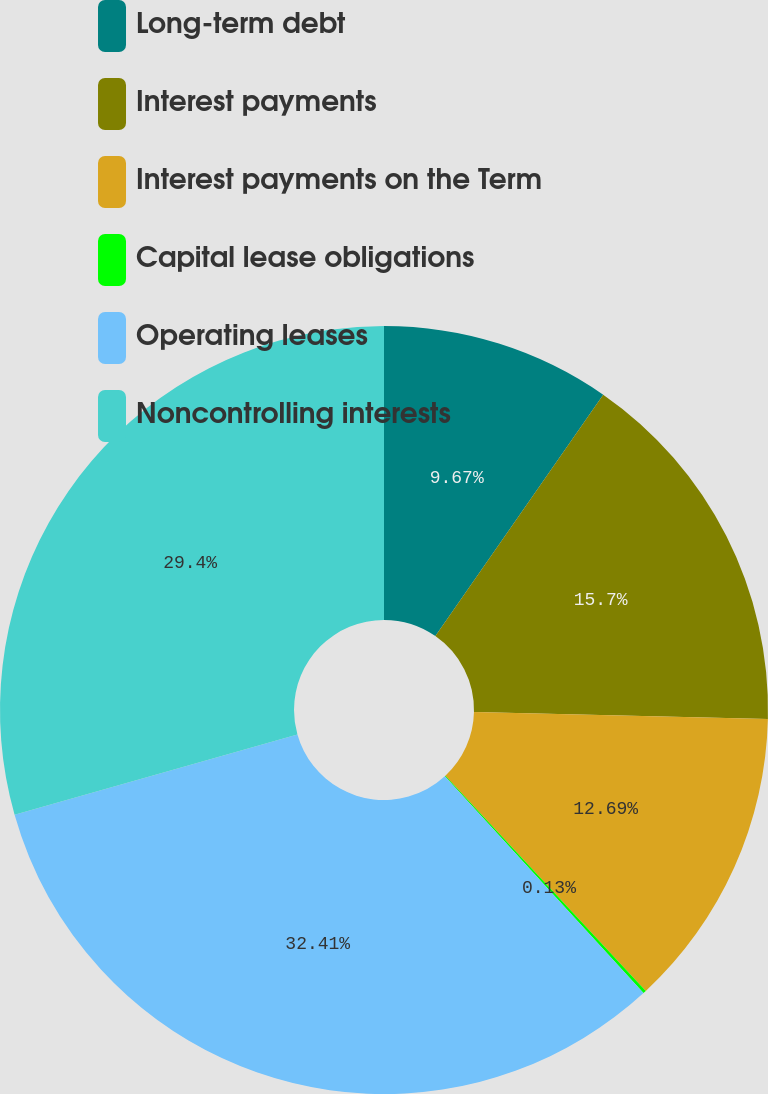Convert chart to OTSL. <chart><loc_0><loc_0><loc_500><loc_500><pie_chart><fcel>Long-term debt<fcel>Interest payments<fcel>Interest payments on the Term<fcel>Capital lease obligations<fcel>Operating leases<fcel>Noncontrolling interests<nl><fcel>9.67%<fcel>15.7%<fcel>12.69%<fcel>0.13%<fcel>32.41%<fcel>29.4%<nl></chart> 